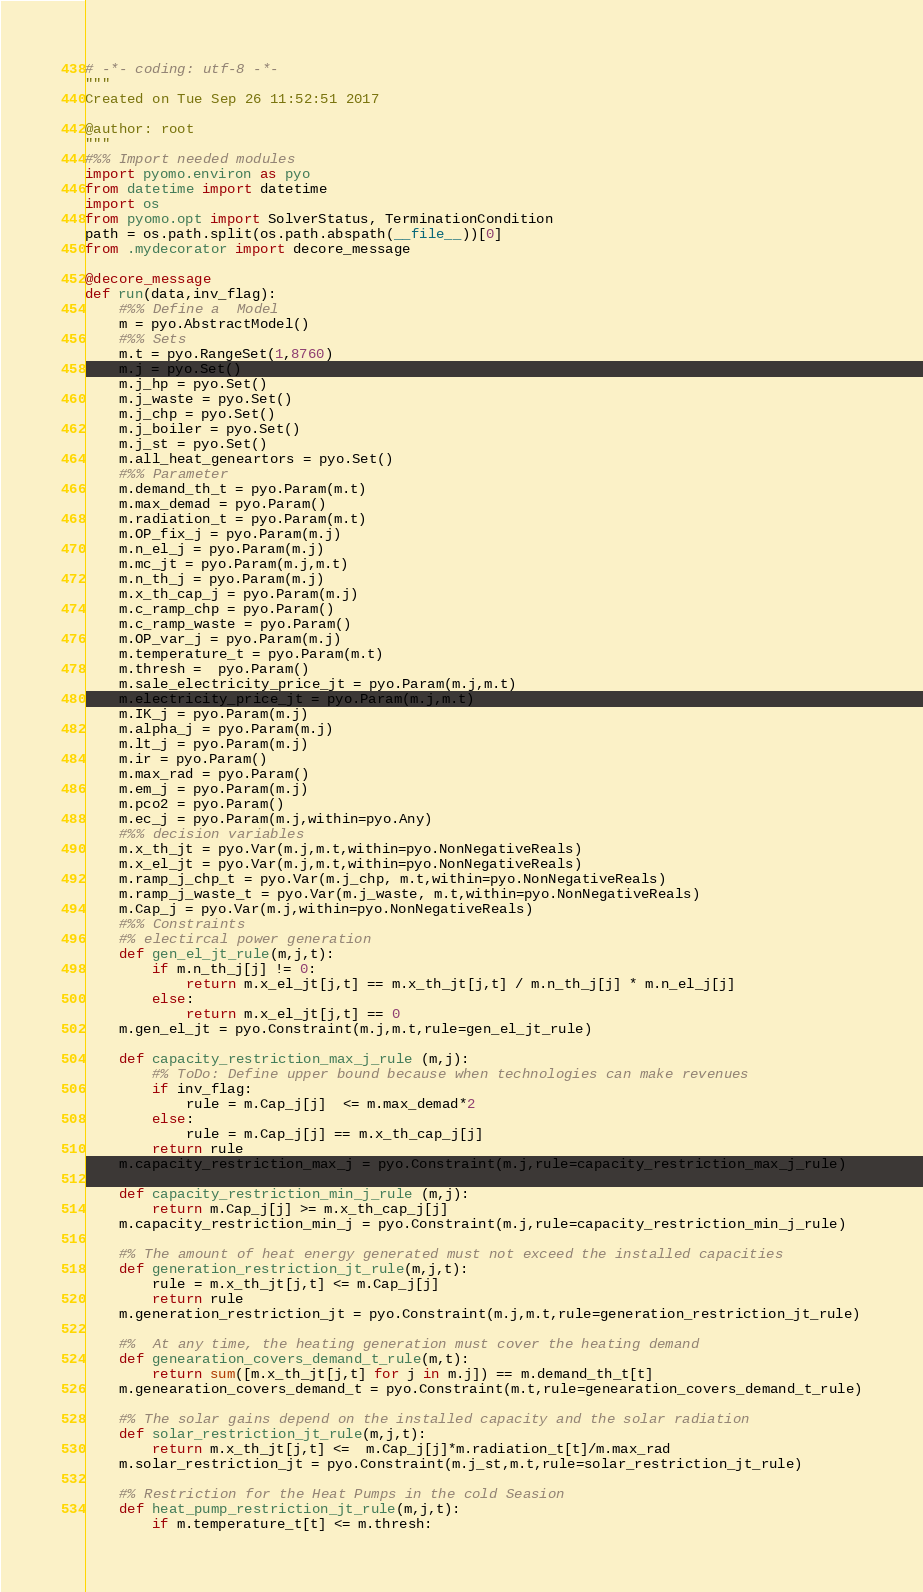<code> <loc_0><loc_0><loc_500><loc_500><_Python_># -*- coding: utf-8 -*-
"""
Created on Tue Sep 26 11:52:51 2017

@author: root
"""
#%% Import needed modules
import pyomo.environ as pyo
from datetime import datetime
import os
from pyomo.opt import SolverStatus, TerminationCondition
path = os.path.split(os.path.abspath(__file__))[0]
from .mydecorator import decore_message

@decore_message
def run(data,inv_flag):
    #%% Define a  Model
    m = pyo.AbstractModel()
    #%% Sets     
    m.t = pyo.RangeSet(1,8760)
    m.j = pyo.Set()
    m.j_hp = pyo.Set()
    m.j_waste = pyo.Set()
    m.j_chp = pyo.Set()
    m.j_boiler = pyo.Set()
    m.j_st = pyo.Set()
    m.all_heat_geneartors = pyo.Set()
    #%% Parameter 
    m.demand_th_t = pyo.Param(m.t)
    m.max_demad = pyo.Param()
    m.radiation_t = pyo.Param(m.t)
    m.OP_fix_j = pyo.Param(m.j)
    m.n_el_j = pyo.Param(m.j)
    m.mc_jt = pyo.Param(m.j,m.t)
    m.n_th_j = pyo.Param(m.j)
    m.x_th_cap_j = pyo.Param(m.j)
    m.c_ramp_chp = pyo.Param()
    m.c_ramp_waste = pyo.Param()
    m.OP_var_j = pyo.Param(m.j)
    m.temperature_t = pyo.Param(m.t)
    m.thresh =  pyo.Param()
    m.sale_electricity_price_jt = pyo.Param(m.j,m.t)
    m.electricity_price_jt = pyo.Param(m.j,m.t)
    m.IK_j = pyo.Param(m.j)
    m.alpha_j = pyo.Param(m.j)
    m.lt_j = pyo.Param(m.j)
    m.ir = pyo.Param()
    m.max_rad = pyo.Param()
    m.em_j = pyo.Param(m.j)
    m.pco2 = pyo.Param()
    m.ec_j = pyo.Param(m.j,within=pyo.Any)
    #%% decision variables 
    m.x_th_jt = pyo.Var(m.j,m.t,within=pyo.NonNegativeReals)
    m.x_el_jt = pyo.Var(m.j,m.t,within=pyo.NonNegativeReals)
    m.ramp_j_chp_t = pyo.Var(m.j_chp, m.t,within=pyo.NonNegativeReals)
    m.ramp_j_waste_t = pyo.Var(m.j_waste, m.t,within=pyo.NonNegativeReals)
    m.Cap_j = pyo.Var(m.j,within=pyo.NonNegativeReals)
    #%% Constraints
    #% electircal power generation
    def gen_el_jt_rule(m,j,t):
        if m.n_th_j[j] != 0:
            return m.x_el_jt[j,t] == m.x_th_jt[j,t] / m.n_th_j[j] * m.n_el_j[j]
        else:
            return m.x_el_jt[j,t] == 0
    m.gen_el_jt = pyo.Constraint(m.j,m.t,rule=gen_el_jt_rule)

    def capacity_restriction_max_j_rule (m,j):
        #% ToDo: Define upper bound because when technologies can make revenues 
        if inv_flag:
            rule = m.Cap_j[j]  <= m.max_demad*2
        else:
            rule = m.Cap_j[j] == m.x_th_cap_j[j]
        return rule
    m.capacity_restriction_max_j = pyo.Constraint(m.j,rule=capacity_restriction_max_j_rule)
    
    def capacity_restriction_min_j_rule (m,j):
        return m.Cap_j[j] >= m.x_th_cap_j[j]
    m.capacity_restriction_min_j = pyo.Constraint(m.j,rule=capacity_restriction_min_j_rule)

    #% The amount of heat energy generated must not exceed the installed capacities
    def generation_restriction_jt_rule(m,j,t):
        rule = m.x_th_jt[j,t] <= m.Cap_j[j]
        return rule
    m.generation_restriction_jt = pyo.Constraint(m.j,m.t,rule=generation_restriction_jt_rule)
    
    #%  At any time, the heating generation must cover the heating demand
    def genearation_covers_demand_t_rule(m,t):
        return sum([m.x_th_jt[j,t] for j in m.j]) == m.demand_th_t[t]
    m.genearation_covers_demand_t = pyo.Constraint(m.t,rule=genearation_covers_demand_t_rule)

    #% The solar gains depend on the installed capacity and the solar radiation
    def solar_restriction_jt_rule(m,j,t):
        return m.x_th_jt[j,t] <=  m.Cap_j[j]*m.radiation_t[t]/m.max_rad
    m.solar_restriction_jt = pyo.Constraint(m.j_st,m.t,rule=solar_restriction_jt_rule)

    #% Restriction for the Heat Pumps in the cold Seasion
    def heat_pump_restriction_jt_rule(m,j,t):
        if m.temperature_t[t] <= m.thresh:</code> 